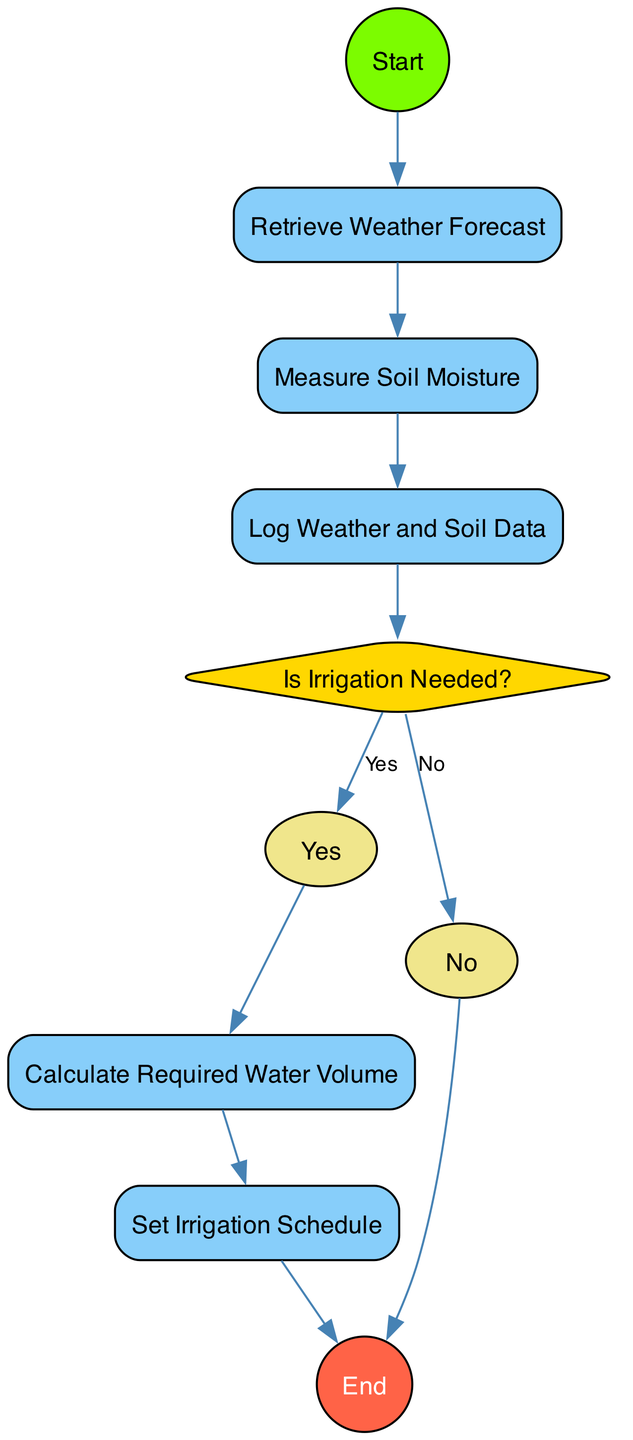What is the first activity in the diagram? The first activity in the diagram is initiated from the "Start" event, which leads to the "Retrieve Weather Forecast".
Answer: Retrieve Weather Forecast How many decision nodes are present in the diagram? There is one decision node which determines whether irrigation is needed.
Answer: 1 What happens if the decision "Is Irrigation Needed?" is 'No'? If irrigation is not needed, the flow goes directly to the "End" event without any irrigation actions being taken.
Answer: End What is the last activity before the flow concludes? The last activity before the flow concludes is the "Set Irrigation Schedule".
Answer: Set Irrigation Schedule What is the outcome if the "Calculate Required Water Volume" activity is completed? If this activity is completed successfully, the next step is to "Set Irrigation Schedule".
Answer: Set Irrigation Schedule What is logged after measuring soil moisture? After measuring soil moisture, the "Log Weather and Soil Data" activity is performed to record the data.
Answer: Log Weather and Soil Data Which node follows the "Measure Soil Moisture" activity? Following "Measure Soil Moisture", the next node is "Log Weather and Soil Data".
Answer: Log Weather and Soil Data What is the purpose of the "Calculate Required Water Volume" activity? The purpose of this activity is to determine how much water is needed based on the soil moisture data and the evapotranspiration equation.
Answer: To determine required water volume What action is taken when irrigation is determined to be needed? If irrigation is determined to be needed, the action taken is to "Calculate Required Water Volume".
Answer: Calculate Required Water Volume 